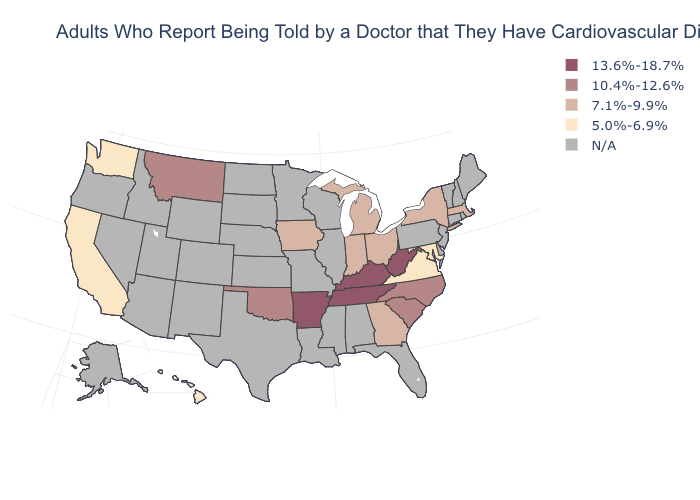Does the map have missing data?
Give a very brief answer. Yes. What is the value of Maine?
Be succinct. N/A. What is the highest value in the Northeast ?
Quick response, please. 7.1%-9.9%. What is the value of Virginia?
Write a very short answer. 5.0%-6.9%. Name the states that have a value in the range 5.0%-6.9%?
Keep it brief. California, Hawaii, Maryland, Virginia, Washington. Name the states that have a value in the range N/A?
Write a very short answer. Alabama, Alaska, Arizona, Colorado, Connecticut, Delaware, Florida, Idaho, Illinois, Kansas, Louisiana, Maine, Minnesota, Mississippi, Missouri, Nebraska, Nevada, New Hampshire, New Jersey, New Mexico, North Dakota, Oregon, Pennsylvania, Rhode Island, South Dakota, Texas, Utah, Vermont, Wisconsin, Wyoming. What is the highest value in the Northeast ?
Keep it brief. 7.1%-9.9%. What is the highest value in states that border Rhode Island?
Write a very short answer. 7.1%-9.9%. What is the value of Pennsylvania?
Concise answer only. N/A. Name the states that have a value in the range N/A?
Short answer required. Alabama, Alaska, Arizona, Colorado, Connecticut, Delaware, Florida, Idaho, Illinois, Kansas, Louisiana, Maine, Minnesota, Mississippi, Missouri, Nebraska, Nevada, New Hampshire, New Jersey, New Mexico, North Dakota, Oregon, Pennsylvania, Rhode Island, South Dakota, Texas, Utah, Vermont, Wisconsin, Wyoming. What is the highest value in states that border Arkansas?
Quick response, please. 13.6%-18.7%. Name the states that have a value in the range 13.6%-18.7%?
Short answer required. Arkansas, Kentucky, Tennessee, West Virginia. What is the value of Alaska?
Be succinct. N/A. What is the highest value in the West ?
Write a very short answer. 10.4%-12.6%. What is the lowest value in the Northeast?
Give a very brief answer. 7.1%-9.9%. 